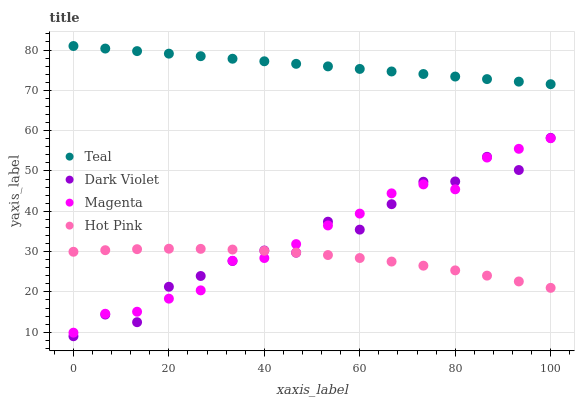Does Hot Pink have the minimum area under the curve?
Answer yes or no. Yes. Does Teal have the maximum area under the curve?
Answer yes or no. Yes. Does Dark Violet have the minimum area under the curve?
Answer yes or no. No. Does Dark Violet have the maximum area under the curve?
Answer yes or no. No. Is Teal the smoothest?
Answer yes or no. Yes. Is Dark Violet the roughest?
Answer yes or no. Yes. Is Hot Pink the smoothest?
Answer yes or no. No. Is Hot Pink the roughest?
Answer yes or no. No. Does Dark Violet have the lowest value?
Answer yes or no. Yes. Does Hot Pink have the lowest value?
Answer yes or no. No. Does Teal have the highest value?
Answer yes or no. Yes. Does Dark Violet have the highest value?
Answer yes or no. No. Is Dark Violet less than Teal?
Answer yes or no. Yes. Is Teal greater than Hot Pink?
Answer yes or no. Yes. Does Hot Pink intersect Dark Violet?
Answer yes or no. Yes. Is Hot Pink less than Dark Violet?
Answer yes or no. No. Is Hot Pink greater than Dark Violet?
Answer yes or no. No. Does Dark Violet intersect Teal?
Answer yes or no. No. 